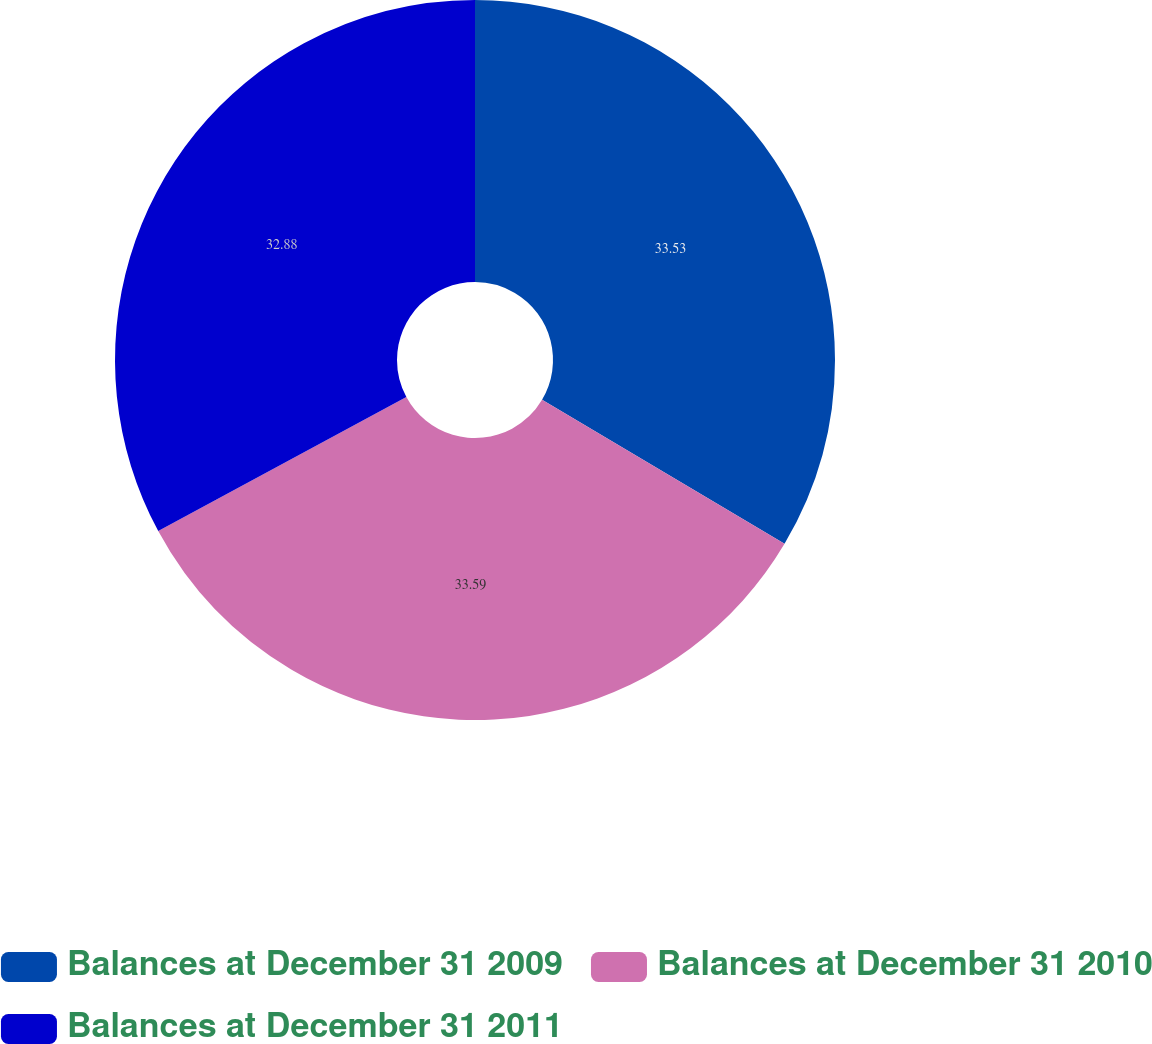Convert chart to OTSL. <chart><loc_0><loc_0><loc_500><loc_500><pie_chart><fcel>Balances at December 31 2009<fcel>Balances at December 31 2010<fcel>Balances at December 31 2011<nl><fcel>33.53%<fcel>33.59%<fcel>32.88%<nl></chart> 